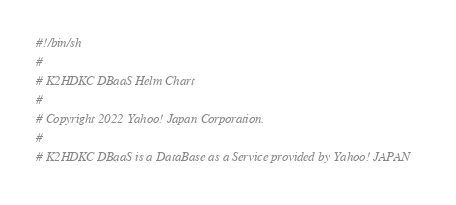Convert code to text. <code><loc_0><loc_0><loc_500><loc_500><_Bash_>#!/bin/sh
#
# K2HDKC DBaaS Helm Chart
#
# Copyright 2022 Yahoo! Japan Corporation.
#
# K2HDKC DBaaS is a DataBase as a Service provided by Yahoo! JAPAN</code> 